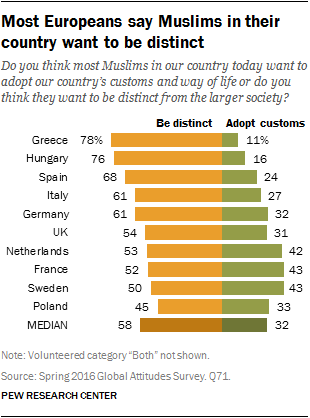Indicate a few pertinent items in this graphic. Let L be the largest bar and s be the smallest bar in the list. Then, add the values of L and s to obtain the sum of the largest and smallest bars in the list. In Greece and Hungary, the average opinion of Be distinct is greater than the median of all Be distinct opinions. 